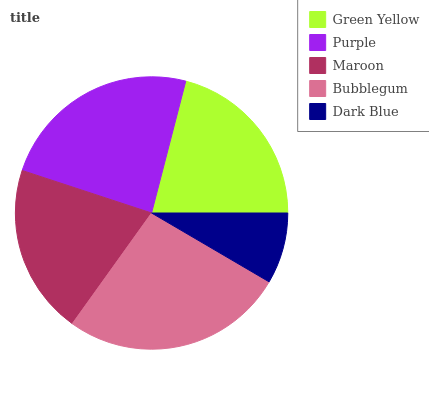Is Dark Blue the minimum?
Answer yes or no. Yes. Is Bubblegum the maximum?
Answer yes or no. Yes. Is Purple the minimum?
Answer yes or no. No. Is Purple the maximum?
Answer yes or no. No. Is Purple greater than Green Yellow?
Answer yes or no. Yes. Is Green Yellow less than Purple?
Answer yes or no. Yes. Is Green Yellow greater than Purple?
Answer yes or no. No. Is Purple less than Green Yellow?
Answer yes or no. No. Is Green Yellow the high median?
Answer yes or no. Yes. Is Green Yellow the low median?
Answer yes or no. Yes. Is Bubblegum the high median?
Answer yes or no. No. Is Dark Blue the low median?
Answer yes or no. No. 